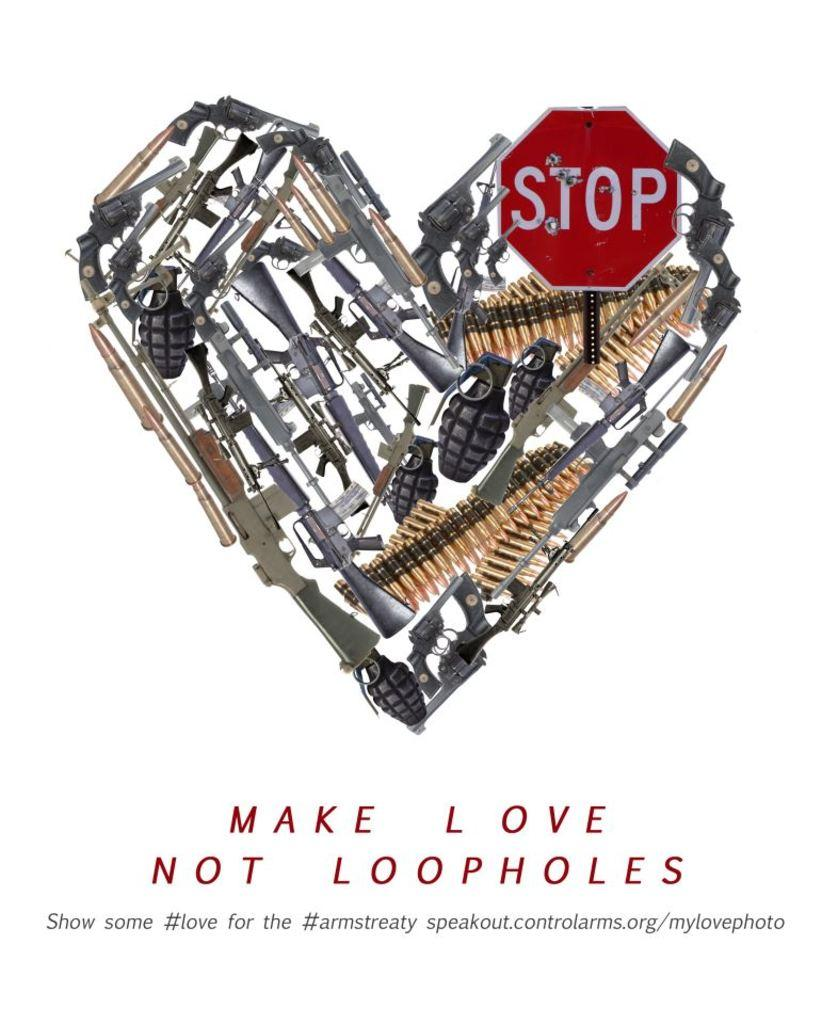<image>
Give a short and clear explanation of the subsequent image. Make love not loopholes include a red stop sign in theheart 